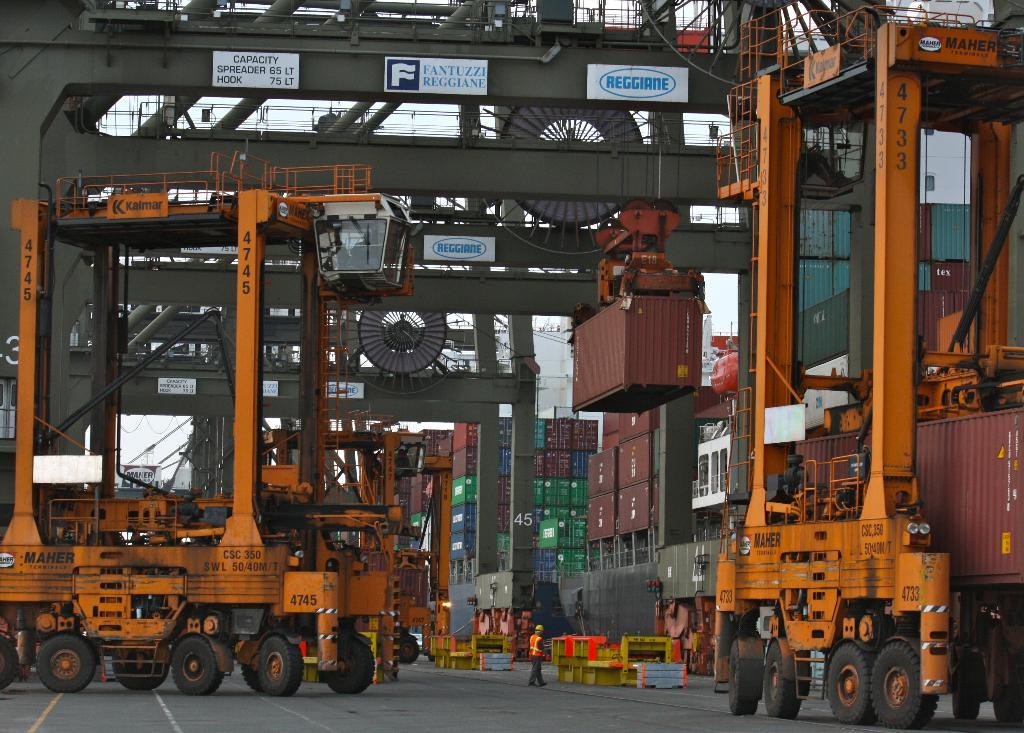What type of vehicles can be seen in the image? There are trucks in the image. Can you describe the vehicles in more detail? Yes, there are vehicles in the image. What is the setting of the image? The image is likely taken in a factory setting. What can be seen in the background of the image? In the background of the image, there are machines and boxes. What else is present in the image besides the vehicles? There is a crowd on the floor in the image. Where is the secretary sitting in the image? There is no secretary present in the image. What type of liquid is being poured into the boxes in the image? There is no liquid being poured into the boxes in the image; the boxes are stationary. 